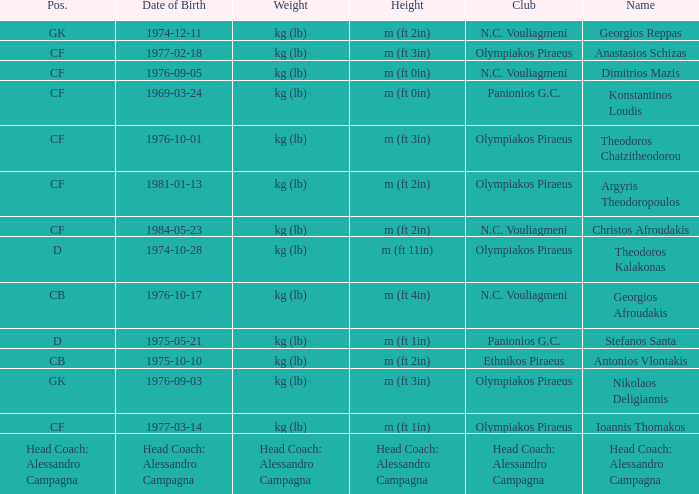What is the weight of the player from club panionios g.c. and was born on 1975-05-21? Kg (lb). Write the full table. {'header': ['Pos.', 'Date of Birth', 'Weight', 'Height', 'Club', 'Name'], 'rows': [['GK', '1974-12-11', 'kg (lb)', 'm (ft 2in)', 'N.C. Vouliagmeni', 'Georgios Reppas'], ['CF', '1977-02-18', 'kg (lb)', 'm (ft 3in)', 'Olympiakos Piraeus', 'Anastasios Schizas'], ['CF', '1976-09-05', 'kg (lb)', 'm (ft 0in)', 'N.C. Vouliagmeni', 'Dimitrios Mazis'], ['CF', '1969-03-24', 'kg (lb)', 'm (ft 0in)', 'Panionios G.C.', 'Konstantinos Loudis'], ['CF', '1976-10-01', 'kg (lb)', 'm (ft 3in)', 'Olympiakos Piraeus', 'Theodoros Chatzitheodorou'], ['CF', '1981-01-13', 'kg (lb)', 'm (ft 2in)', 'Olympiakos Piraeus', 'Argyris Theodoropoulos'], ['CF', '1984-05-23', 'kg (lb)', 'm (ft 2in)', 'N.C. Vouliagmeni', 'Christos Afroudakis'], ['D', '1974-10-28', 'kg (lb)', 'm (ft 11in)', 'Olympiakos Piraeus', 'Theodoros Kalakonas'], ['CB', '1976-10-17', 'kg (lb)', 'm (ft 4in)', 'N.C. Vouliagmeni', 'Georgios Afroudakis'], ['D', '1975-05-21', 'kg (lb)', 'm (ft 1in)', 'Panionios G.C.', 'Stefanos Santa'], ['CB', '1975-10-10', 'kg (lb)', 'm (ft 2in)', 'Ethnikos Piraeus', 'Antonios Vlontakis'], ['GK', '1976-09-03', 'kg (lb)', 'm (ft 3in)', 'Olympiakos Piraeus', 'Nikolaos Deligiannis'], ['CF', '1977-03-14', 'kg (lb)', 'm (ft 1in)', 'Olympiakos Piraeus', 'Ioannis Thomakos'], ['Head Coach: Alessandro Campagna', 'Head Coach: Alessandro Campagna', 'Head Coach: Alessandro Campagna', 'Head Coach: Alessandro Campagna', 'Head Coach: Alessandro Campagna', 'Head Coach: Alessandro Campagna']]} 